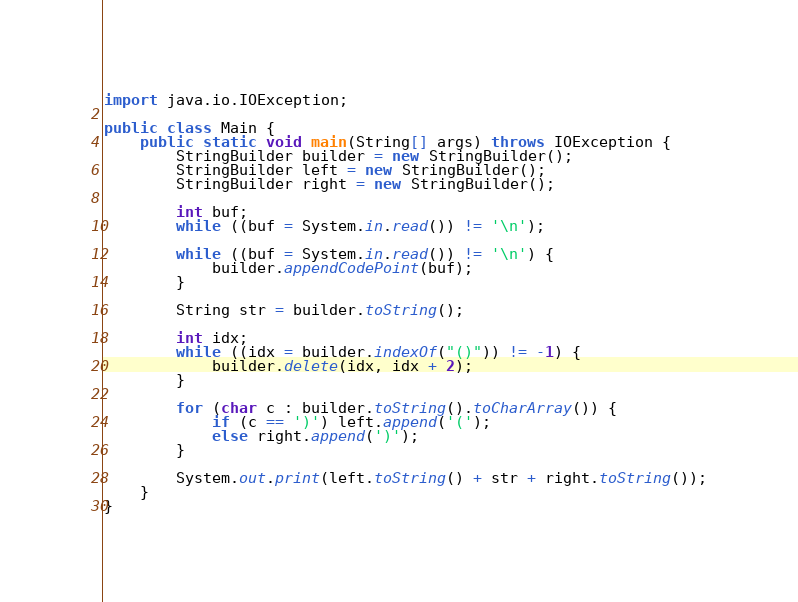Convert code to text. <code><loc_0><loc_0><loc_500><loc_500><_Java_>import java.io.IOException;

public class Main {
    public static void main(String[] args) throws IOException {
        StringBuilder builder = new StringBuilder();
        StringBuilder left = new StringBuilder();
        StringBuilder right = new StringBuilder();
        
        int buf;
        while ((buf = System.in.read()) != '\n');
        
        while ((buf = System.in.read()) != '\n') {
            builder.appendCodePoint(buf);
        }
        
        String str = builder.toString();
        
        int idx;
        while ((idx = builder.indexOf("()")) != -1) {
            builder.delete(idx, idx + 2);
        }

        for (char c : builder.toString().toCharArray()) {
            if (c == ')') left.append('(');
            else right.append(')');
        }

        System.out.print(left.toString() + str + right.toString());
    }
}
</code> 